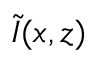<formula> <loc_0><loc_0><loc_500><loc_500>\tilde { I } ( x , z )</formula> 